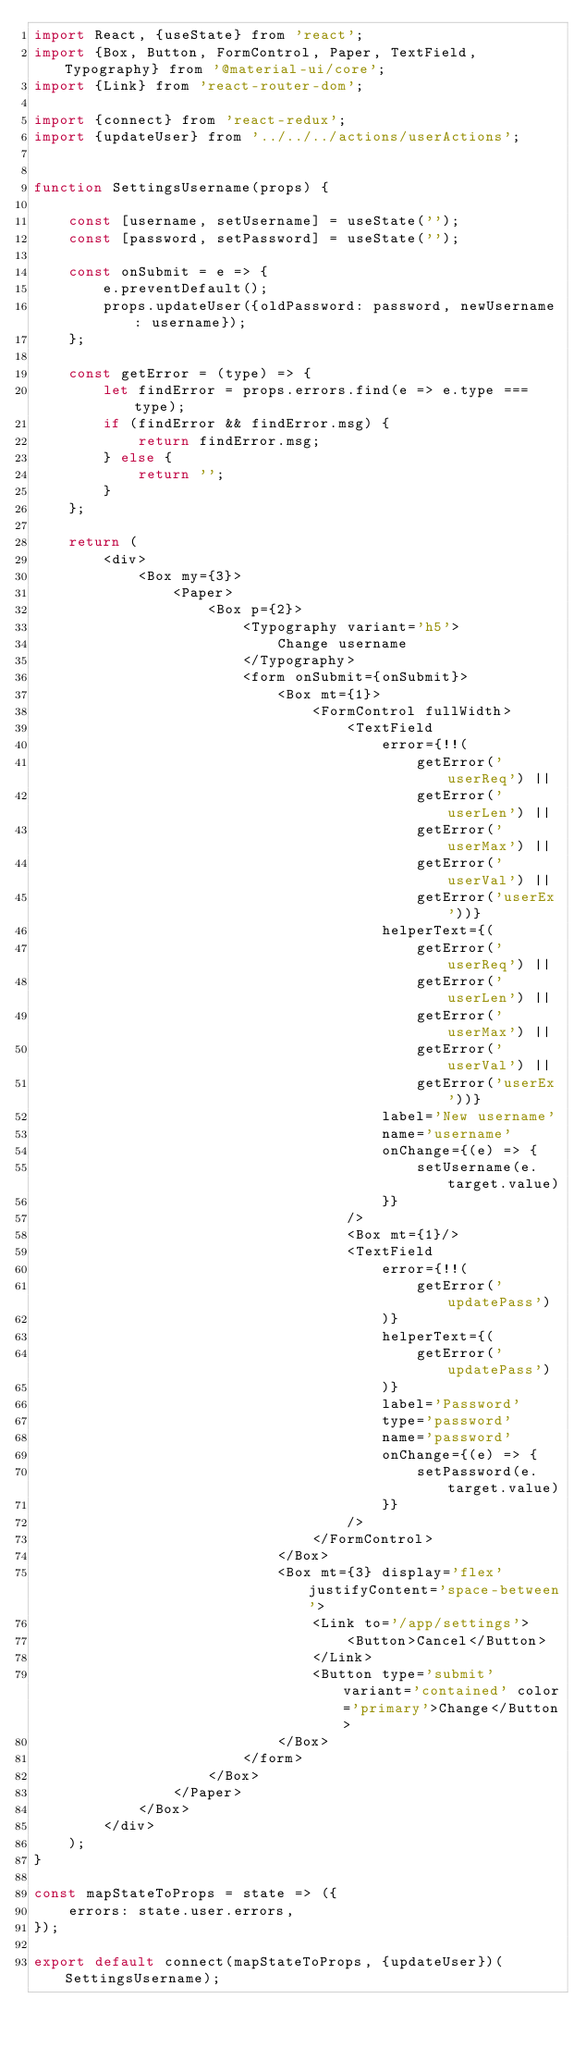<code> <loc_0><loc_0><loc_500><loc_500><_JavaScript_>import React, {useState} from 'react';
import {Box, Button, FormControl, Paper, TextField, Typography} from '@material-ui/core';
import {Link} from 'react-router-dom';

import {connect} from 'react-redux';
import {updateUser} from '../../../actions/userActions';


function SettingsUsername(props) {
    
    const [username, setUsername] = useState('');
    const [password, setPassword] = useState('');
    
    const onSubmit = e => {
        e.preventDefault();
        props.updateUser({oldPassword: password, newUsername: username});
    };
    
    const getError = (type) => {
        let findError = props.errors.find(e => e.type === type);
        if (findError && findError.msg) {
            return findError.msg;
        } else {
            return '';
        }
    };
    
    return (
        <div>
            <Box my={3}>
                <Paper>
                    <Box p={2}>
                        <Typography variant='h5'>
                            Change username
                        </Typography>
                        <form onSubmit={onSubmit}>
                            <Box mt={1}>
                                <FormControl fullWidth>
                                    <TextField
                                        error={!!(
                                            getError('userReq') ||
                                            getError('userLen') ||
                                            getError('userMax') ||
                                            getError('userVal') ||
                                            getError('userEx'))}
                                        helperText={(
                                            getError('userReq') ||
                                            getError('userLen') ||
                                            getError('userMax') ||
                                            getError('userVal') ||
                                            getError('userEx'))}
                                        label='New username'
                                        name='username'
                                        onChange={(e) => {
                                            setUsername(e.target.value)
                                        }}
                                    />
                                    <Box mt={1}/>
                                    <TextField
                                        error={!!(
                                            getError('updatePass')
                                        )}
                                        helperText={(
                                            getError('updatePass')
                                        )}
                                        label='Password'
                                        type='password'
                                        name='password'
                                        onChange={(e) => {
                                            setPassword(e.target.value)
                                        }}
                                    />
                                </FormControl>
                            </Box>
                            <Box mt={3} display='flex' justifyContent='space-between'>
                                <Link to='/app/settings'>
                                    <Button>Cancel</Button>
                                </Link>
                                <Button type='submit' variant='contained' color='primary'>Change</Button>
                            </Box>
                        </form>
                    </Box>
                </Paper>
            </Box>
        </div>
    );
}

const mapStateToProps = state => ({
    errors: state.user.errors,
});

export default connect(mapStateToProps, {updateUser})(SettingsUsername);
</code> 